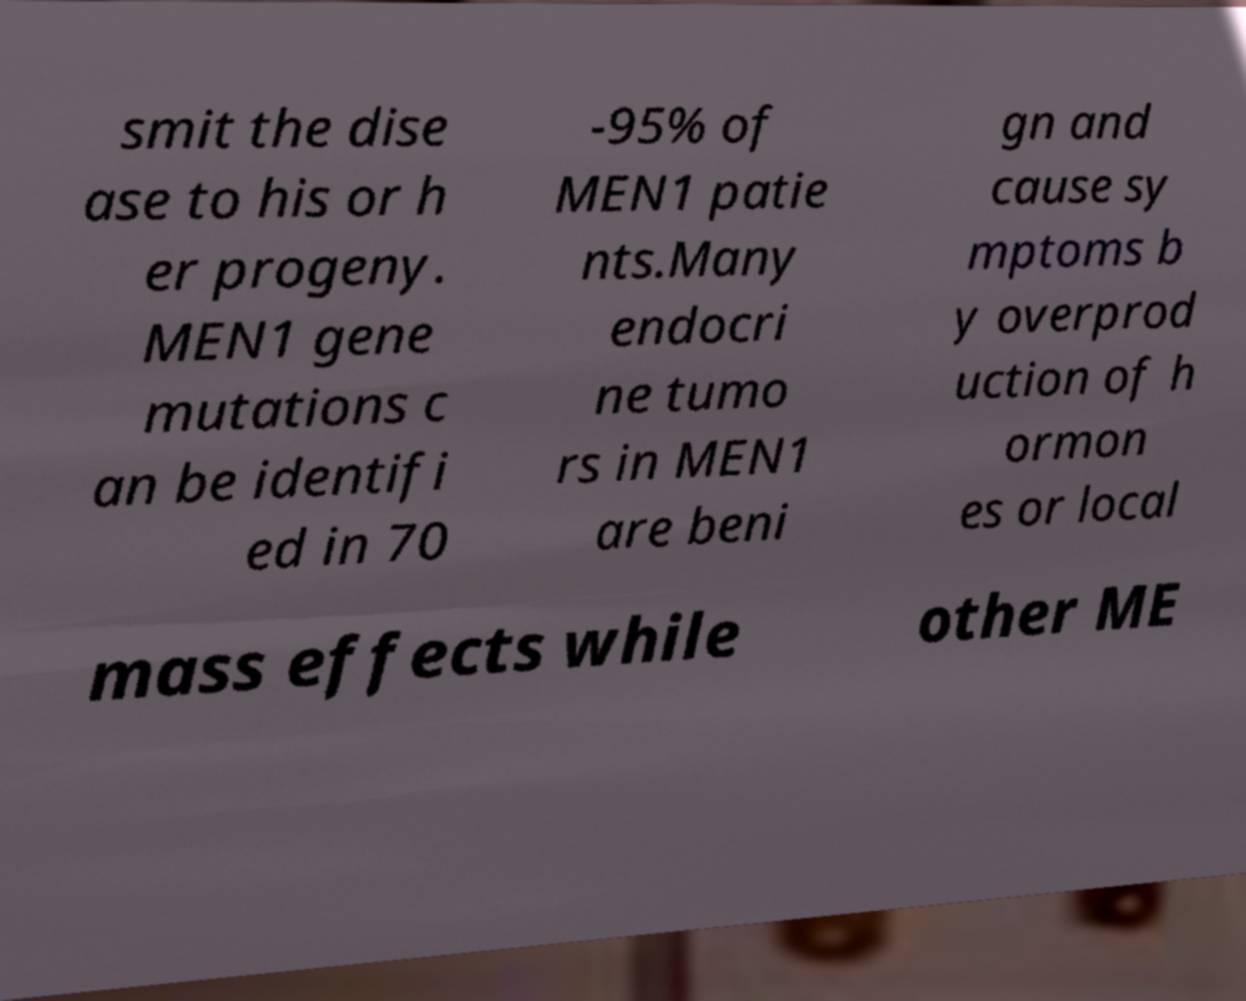Please read and relay the text visible in this image. What does it say? smit the dise ase to his or h er progeny. MEN1 gene mutations c an be identifi ed in 70 -95% of MEN1 patie nts.Many endocri ne tumo rs in MEN1 are beni gn and cause sy mptoms b y overprod uction of h ormon es or local mass effects while other ME 